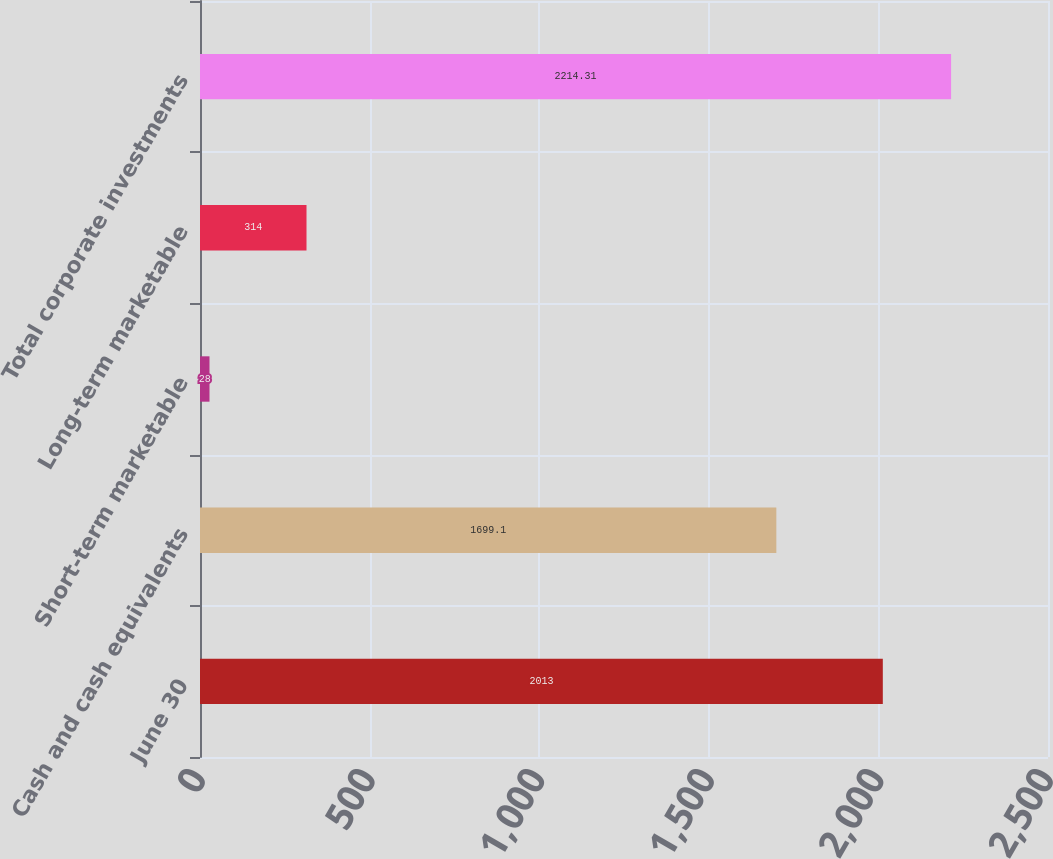Convert chart. <chart><loc_0><loc_0><loc_500><loc_500><bar_chart><fcel>June 30<fcel>Cash and cash equivalents<fcel>Short-term marketable<fcel>Long-term marketable<fcel>Total corporate investments<nl><fcel>2013<fcel>1699.1<fcel>28<fcel>314<fcel>2214.31<nl></chart> 